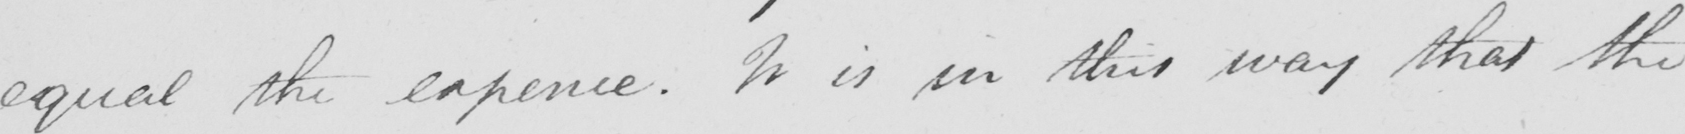What is written in this line of handwriting? equal the expence . It is in this way that the 